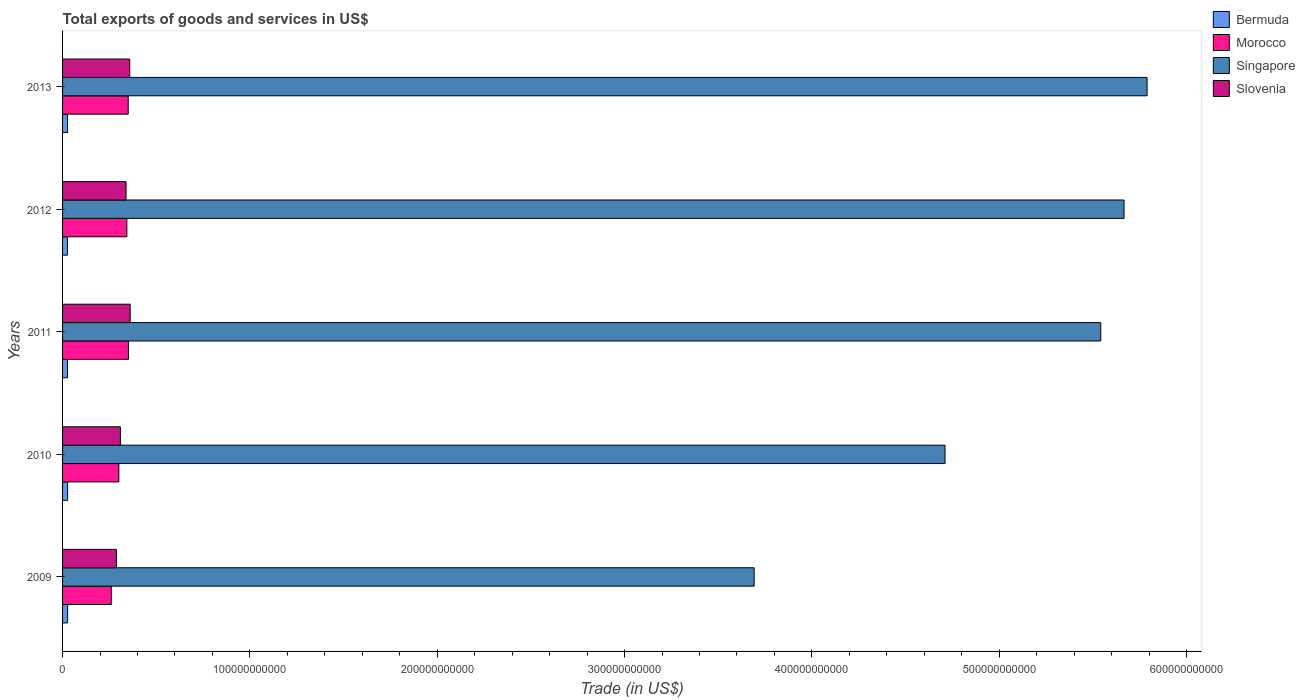How many different coloured bars are there?
Your response must be concise. 4. How many groups of bars are there?
Keep it short and to the point. 5. Are the number of bars per tick equal to the number of legend labels?
Your response must be concise. Yes. Are the number of bars on each tick of the Y-axis equal?
Ensure brevity in your answer.  Yes. In how many cases, is the number of bars for a given year not equal to the number of legend labels?
Your answer should be compact. 0. What is the total exports of goods and services in Bermuda in 2013?
Provide a succinct answer. 2.66e+09. Across all years, what is the maximum total exports of goods and services in Slovenia?
Your answer should be compact. 3.61e+1. Across all years, what is the minimum total exports of goods and services in Singapore?
Provide a short and direct response. 3.69e+11. In which year was the total exports of goods and services in Bermuda minimum?
Keep it short and to the point. 2012. What is the total total exports of goods and services in Bermuda in the graph?
Ensure brevity in your answer.  1.33e+1. What is the difference between the total exports of goods and services in Slovenia in 2009 and that in 2012?
Make the answer very short. -5.13e+09. What is the difference between the total exports of goods and services in Singapore in 2010 and the total exports of goods and services in Bermuda in 2011?
Provide a succinct answer. 4.68e+11. What is the average total exports of goods and services in Morocco per year?
Your answer should be very brief. 3.21e+1. In the year 2012, what is the difference between the total exports of goods and services in Bermuda and total exports of goods and services in Slovenia?
Keep it short and to the point. -3.13e+1. What is the ratio of the total exports of goods and services in Morocco in 2010 to that in 2012?
Give a very brief answer. 0.88. Is the total exports of goods and services in Morocco in 2011 less than that in 2012?
Provide a short and direct response. No. Is the difference between the total exports of goods and services in Bermuda in 2010 and 2011 greater than the difference between the total exports of goods and services in Slovenia in 2010 and 2011?
Provide a short and direct response. Yes. What is the difference between the highest and the second highest total exports of goods and services in Morocco?
Make the answer very short. 1.34e+08. What is the difference between the highest and the lowest total exports of goods and services in Morocco?
Your answer should be compact. 9.16e+09. Is it the case that in every year, the sum of the total exports of goods and services in Bermuda and total exports of goods and services in Singapore is greater than the sum of total exports of goods and services in Morocco and total exports of goods and services in Slovenia?
Give a very brief answer. Yes. What does the 1st bar from the top in 2013 represents?
Your answer should be very brief. Slovenia. What does the 3rd bar from the bottom in 2013 represents?
Your response must be concise. Singapore. How many bars are there?
Offer a terse response. 20. Are all the bars in the graph horizontal?
Your answer should be compact. Yes. What is the difference between two consecutive major ticks on the X-axis?
Your answer should be very brief. 1.00e+11. Does the graph contain any zero values?
Offer a very short reply. No. Does the graph contain grids?
Offer a very short reply. No. Where does the legend appear in the graph?
Ensure brevity in your answer.  Top right. What is the title of the graph?
Your response must be concise. Total exports of goods and services in US$. Does "Bhutan" appear as one of the legend labels in the graph?
Your answer should be very brief. No. What is the label or title of the X-axis?
Keep it short and to the point. Trade (in US$). What is the Trade (in US$) in Bermuda in 2009?
Make the answer very short. 2.70e+09. What is the Trade (in US$) in Morocco in 2009?
Offer a very short reply. 2.60e+1. What is the Trade (in US$) of Singapore in 2009?
Provide a succinct answer. 3.69e+11. What is the Trade (in US$) of Slovenia in 2009?
Keep it short and to the point. 2.88e+1. What is the Trade (in US$) in Bermuda in 2010?
Ensure brevity in your answer.  2.70e+09. What is the Trade (in US$) in Morocco in 2010?
Your response must be concise. 3.00e+1. What is the Trade (in US$) in Singapore in 2010?
Ensure brevity in your answer.  4.71e+11. What is the Trade (in US$) of Slovenia in 2010?
Offer a very short reply. 3.09e+1. What is the Trade (in US$) of Bermuda in 2011?
Make the answer very short. 2.64e+09. What is the Trade (in US$) in Morocco in 2011?
Keep it short and to the point. 3.52e+1. What is the Trade (in US$) in Singapore in 2011?
Give a very brief answer. 5.54e+11. What is the Trade (in US$) in Slovenia in 2011?
Make the answer very short. 3.61e+1. What is the Trade (in US$) in Bermuda in 2012?
Give a very brief answer. 2.59e+09. What is the Trade (in US$) in Morocco in 2012?
Offer a terse response. 3.43e+1. What is the Trade (in US$) of Singapore in 2012?
Offer a terse response. 5.67e+11. What is the Trade (in US$) in Slovenia in 2012?
Make the answer very short. 3.39e+1. What is the Trade (in US$) in Bermuda in 2013?
Provide a short and direct response. 2.66e+09. What is the Trade (in US$) in Morocco in 2013?
Make the answer very short. 3.50e+1. What is the Trade (in US$) in Singapore in 2013?
Make the answer very short. 5.79e+11. What is the Trade (in US$) of Slovenia in 2013?
Ensure brevity in your answer.  3.59e+1. Across all years, what is the maximum Trade (in US$) in Bermuda?
Your answer should be compact. 2.70e+09. Across all years, what is the maximum Trade (in US$) in Morocco?
Keep it short and to the point. 3.52e+1. Across all years, what is the maximum Trade (in US$) in Singapore?
Keep it short and to the point. 5.79e+11. Across all years, what is the maximum Trade (in US$) in Slovenia?
Offer a terse response. 3.61e+1. Across all years, what is the minimum Trade (in US$) in Bermuda?
Provide a short and direct response. 2.59e+09. Across all years, what is the minimum Trade (in US$) of Morocco?
Keep it short and to the point. 2.60e+1. Across all years, what is the minimum Trade (in US$) in Singapore?
Your response must be concise. 3.69e+11. Across all years, what is the minimum Trade (in US$) of Slovenia?
Your response must be concise. 2.88e+1. What is the total Trade (in US$) in Bermuda in the graph?
Provide a short and direct response. 1.33e+1. What is the total Trade (in US$) of Morocco in the graph?
Your answer should be very brief. 1.61e+11. What is the total Trade (in US$) in Singapore in the graph?
Ensure brevity in your answer.  2.54e+12. What is the total Trade (in US$) in Slovenia in the graph?
Keep it short and to the point. 1.65e+11. What is the difference between the Trade (in US$) in Bermuda in 2009 and that in 2010?
Make the answer very short. -5.34e+06. What is the difference between the Trade (in US$) in Morocco in 2009 and that in 2010?
Your answer should be compact. -4.03e+09. What is the difference between the Trade (in US$) of Singapore in 2009 and that in 2010?
Ensure brevity in your answer.  -1.02e+11. What is the difference between the Trade (in US$) of Slovenia in 2009 and that in 2010?
Provide a succinct answer. -2.11e+09. What is the difference between the Trade (in US$) of Bermuda in 2009 and that in 2011?
Your response must be concise. 5.51e+07. What is the difference between the Trade (in US$) of Morocco in 2009 and that in 2011?
Offer a terse response. -9.16e+09. What is the difference between the Trade (in US$) in Singapore in 2009 and that in 2011?
Offer a very short reply. -1.85e+11. What is the difference between the Trade (in US$) of Slovenia in 2009 and that in 2011?
Offer a terse response. -7.33e+09. What is the difference between the Trade (in US$) of Bermuda in 2009 and that in 2012?
Offer a very short reply. 1.10e+08. What is the difference between the Trade (in US$) in Morocco in 2009 and that in 2012?
Provide a short and direct response. -8.31e+09. What is the difference between the Trade (in US$) in Singapore in 2009 and that in 2012?
Make the answer very short. -1.97e+11. What is the difference between the Trade (in US$) of Slovenia in 2009 and that in 2012?
Make the answer very short. -5.13e+09. What is the difference between the Trade (in US$) of Bermuda in 2009 and that in 2013?
Provide a succinct answer. 4.24e+07. What is the difference between the Trade (in US$) in Morocco in 2009 and that in 2013?
Offer a terse response. -9.03e+09. What is the difference between the Trade (in US$) of Singapore in 2009 and that in 2013?
Ensure brevity in your answer.  -2.10e+11. What is the difference between the Trade (in US$) of Slovenia in 2009 and that in 2013?
Keep it short and to the point. -7.09e+09. What is the difference between the Trade (in US$) of Bermuda in 2010 and that in 2011?
Your answer should be very brief. 6.04e+07. What is the difference between the Trade (in US$) of Morocco in 2010 and that in 2011?
Make the answer very short. -5.13e+09. What is the difference between the Trade (in US$) in Singapore in 2010 and that in 2011?
Offer a very short reply. -8.31e+1. What is the difference between the Trade (in US$) of Slovenia in 2010 and that in 2011?
Offer a very short reply. -5.22e+09. What is the difference between the Trade (in US$) of Bermuda in 2010 and that in 2012?
Give a very brief answer. 1.15e+08. What is the difference between the Trade (in US$) of Morocco in 2010 and that in 2012?
Give a very brief answer. -4.28e+09. What is the difference between the Trade (in US$) of Singapore in 2010 and that in 2012?
Offer a terse response. -9.56e+1. What is the difference between the Trade (in US$) in Slovenia in 2010 and that in 2012?
Provide a succinct answer. -3.03e+09. What is the difference between the Trade (in US$) of Bermuda in 2010 and that in 2013?
Provide a short and direct response. 4.78e+07. What is the difference between the Trade (in US$) in Morocco in 2010 and that in 2013?
Provide a short and direct response. -5.00e+09. What is the difference between the Trade (in US$) of Singapore in 2010 and that in 2013?
Offer a very short reply. -1.08e+11. What is the difference between the Trade (in US$) in Slovenia in 2010 and that in 2013?
Your response must be concise. -4.99e+09. What is the difference between the Trade (in US$) in Bermuda in 2011 and that in 2012?
Keep it short and to the point. 5.48e+07. What is the difference between the Trade (in US$) in Morocco in 2011 and that in 2012?
Offer a terse response. 8.52e+08. What is the difference between the Trade (in US$) in Singapore in 2011 and that in 2012?
Make the answer very short. -1.24e+1. What is the difference between the Trade (in US$) in Slovenia in 2011 and that in 2012?
Give a very brief answer. 2.20e+09. What is the difference between the Trade (in US$) of Bermuda in 2011 and that in 2013?
Your answer should be very brief. -1.27e+07. What is the difference between the Trade (in US$) in Morocco in 2011 and that in 2013?
Provide a short and direct response. 1.34e+08. What is the difference between the Trade (in US$) in Singapore in 2011 and that in 2013?
Ensure brevity in your answer.  -2.47e+1. What is the difference between the Trade (in US$) of Slovenia in 2011 and that in 2013?
Your answer should be compact. 2.38e+08. What is the difference between the Trade (in US$) of Bermuda in 2012 and that in 2013?
Provide a short and direct response. -6.75e+07. What is the difference between the Trade (in US$) in Morocco in 2012 and that in 2013?
Give a very brief answer. -7.18e+08. What is the difference between the Trade (in US$) in Singapore in 2012 and that in 2013?
Offer a terse response. -1.23e+1. What is the difference between the Trade (in US$) in Slovenia in 2012 and that in 2013?
Offer a terse response. -1.96e+09. What is the difference between the Trade (in US$) of Bermuda in 2009 and the Trade (in US$) of Morocco in 2010?
Keep it short and to the point. -2.73e+1. What is the difference between the Trade (in US$) of Bermuda in 2009 and the Trade (in US$) of Singapore in 2010?
Offer a very short reply. -4.68e+11. What is the difference between the Trade (in US$) of Bermuda in 2009 and the Trade (in US$) of Slovenia in 2010?
Provide a short and direct response. -2.82e+1. What is the difference between the Trade (in US$) in Morocco in 2009 and the Trade (in US$) in Singapore in 2010?
Provide a succinct answer. -4.45e+11. What is the difference between the Trade (in US$) of Morocco in 2009 and the Trade (in US$) of Slovenia in 2010?
Your response must be concise. -4.85e+09. What is the difference between the Trade (in US$) in Singapore in 2009 and the Trade (in US$) in Slovenia in 2010?
Give a very brief answer. 3.38e+11. What is the difference between the Trade (in US$) of Bermuda in 2009 and the Trade (in US$) of Morocco in 2011?
Give a very brief answer. -3.25e+1. What is the difference between the Trade (in US$) in Bermuda in 2009 and the Trade (in US$) in Singapore in 2011?
Provide a succinct answer. -5.52e+11. What is the difference between the Trade (in US$) in Bermuda in 2009 and the Trade (in US$) in Slovenia in 2011?
Ensure brevity in your answer.  -3.34e+1. What is the difference between the Trade (in US$) in Morocco in 2009 and the Trade (in US$) in Singapore in 2011?
Your answer should be very brief. -5.28e+11. What is the difference between the Trade (in US$) in Morocco in 2009 and the Trade (in US$) in Slovenia in 2011?
Keep it short and to the point. -1.01e+1. What is the difference between the Trade (in US$) in Singapore in 2009 and the Trade (in US$) in Slovenia in 2011?
Give a very brief answer. 3.33e+11. What is the difference between the Trade (in US$) of Bermuda in 2009 and the Trade (in US$) of Morocco in 2012?
Ensure brevity in your answer.  -3.16e+1. What is the difference between the Trade (in US$) in Bermuda in 2009 and the Trade (in US$) in Singapore in 2012?
Offer a very short reply. -5.64e+11. What is the difference between the Trade (in US$) of Bermuda in 2009 and the Trade (in US$) of Slovenia in 2012?
Make the answer very short. -3.12e+1. What is the difference between the Trade (in US$) in Morocco in 2009 and the Trade (in US$) in Singapore in 2012?
Make the answer very short. -5.41e+11. What is the difference between the Trade (in US$) in Morocco in 2009 and the Trade (in US$) in Slovenia in 2012?
Keep it short and to the point. -7.88e+09. What is the difference between the Trade (in US$) in Singapore in 2009 and the Trade (in US$) in Slovenia in 2012?
Provide a short and direct response. 3.35e+11. What is the difference between the Trade (in US$) of Bermuda in 2009 and the Trade (in US$) of Morocco in 2013?
Provide a succinct answer. -3.23e+1. What is the difference between the Trade (in US$) in Bermuda in 2009 and the Trade (in US$) in Singapore in 2013?
Provide a succinct answer. -5.76e+11. What is the difference between the Trade (in US$) of Bermuda in 2009 and the Trade (in US$) of Slovenia in 2013?
Your response must be concise. -3.32e+1. What is the difference between the Trade (in US$) in Morocco in 2009 and the Trade (in US$) in Singapore in 2013?
Give a very brief answer. -5.53e+11. What is the difference between the Trade (in US$) in Morocco in 2009 and the Trade (in US$) in Slovenia in 2013?
Your answer should be very brief. -9.84e+09. What is the difference between the Trade (in US$) of Singapore in 2009 and the Trade (in US$) of Slovenia in 2013?
Make the answer very short. 3.33e+11. What is the difference between the Trade (in US$) of Bermuda in 2010 and the Trade (in US$) of Morocco in 2011?
Offer a very short reply. -3.25e+1. What is the difference between the Trade (in US$) in Bermuda in 2010 and the Trade (in US$) in Singapore in 2011?
Provide a short and direct response. -5.52e+11. What is the difference between the Trade (in US$) in Bermuda in 2010 and the Trade (in US$) in Slovenia in 2011?
Provide a short and direct response. -3.34e+1. What is the difference between the Trade (in US$) of Morocco in 2010 and the Trade (in US$) of Singapore in 2011?
Your response must be concise. -5.24e+11. What is the difference between the Trade (in US$) in Morocco in 2010 and the Trade (in US$) in Slovenia in 2011?
Offer a very short reply. -6.05e+09. What is the difference between the Trade (in US$) in Singapore in 2010 and the Trade (in US$) in Slovenia in 2011?
Provide a short and direct response. 4.35e+11. What is the difference between the Trade (in US$) in Bermuda in 2010 and the Trade (in US$) in Morocco in 2012?
Give a very brief answer. -3.16e+1. What is the difference between the Trade (in US$) of Bermuda in 2010 and the Trade (in US$) of Singapore in 2012?
Make the answer very short. -5.64e+11. What is the difference between the Trade (in US$) of Bermuda in 2010 and the Trade (in US$) of Slovenia in 2012?
Your answer should be very brief. -3.12e+1. What is the difference between the Trade (in US$) of Morocco in 2010 and the Trade (in US$) of Singapore in 2012?
Your answer should be very brief. -5.37e+11. What is the difference between the Trade (in US$) in Morocco in 2010 and the Trade (in US$) in Slovenia in 2012?
Keep it short and to the point. -3.85e+09. What is the difference between the Trade (in US$) in Singapore in 2010 and the Trade (in US$) in Slovenia in 2012?
Your answer should be compact. 4.37e+11. What is the difference between the Trade (in US$) of Bermuda in 2010 and the Trade (in US$) of Morocco in 2013?
Give a very brief answer. -3.23e+1. What is the difference between the Trade (in US$) of Bermuda in 2010 and the Trade (in US$) of Singapore in 2013?
Give a very brief answer. -5.76e+11. What is the difference between the Trade (in US$) in Bermuda in 2010 and the Trade (in US$) in Slovenia in 2013?
Make the answer very short. -3.32e+1. What is the difference between the Trade (in US$) in Morocco in 2010 and the Trade (in US$) in Singapore in 2013?
Your answer should be very brief. -5.49e+11. What is the difference between the Trade (in US$) in Morocco in 2010 and the Trade (in US$) in Slovenia in 2013?
Give a very brief answer. -5.81e+09. What is the difference between the Trade (in US$) of Singapore in 2010 and the Trade (in US$) of Slovenia in 2013?
Keep it short and to the point. 4.35e+11. What is the difference between the Trade (in US$) in Bermuda in 2011 and the Trade (in US$) in Morocco in 2012?
Keep it short and to the point. -3.17e+1. What is the difference between the Trade (in US$) in Bermuda in 2011 and the Trade (in US$) in Singapore in 2012?
Keep it short and to the point. -5.64e+11. What is the difference between the Trade (in US$) in Bermuda in 2011 and the Trade (in US$) in Slovenia in 2012?
Your answer should be compact. -3.13e+1. What is the difference between the Trade (in US$) of Morocco in 2011 and the Trade (in US$) of Singapore in 2012?
Offer a terse response. -5.31e+11. What is the difference between the Trade (in US$) of Morocco in 2011 and the Trade (in US$) of Slovenia in 2012?
Provide a short and direct response. 1.28e+09. What is the difference between the Trade (in US$) in Singapore in 2011 and the Trade (in US$) in Slovenia in 2012?
Provide a short and direct response. 5.20e+11. What is the difference between the Trade (in US$) of Bermuda in 2011 and the Trade (in US$) of Morocco in 2013?
Offer a very short reply. -3.24e+1. What is the difference between the Trade (in US$) of Bermuda in 2011 and the Trade (in US$) of Singapore in 2013?
Your response must be concise. -5.76e+11. What is the difference between the Trade (in US$) in Bermuda in 2011 and the Trade (in US$) in Slovenia in 2013?
Your response must be concise. -3.32e+1. What is the difference between the Trade (in US$) of Morocco in 2011 and the Trade (in US$) of Singapore in 2013?
Your answer should be compact. -5.44e+11. What is the difference between the Trade (in US$) of Morocco in 2011 and the Trade (in US$) of Slovenia in 2013?
Your answer should be compact. -6.80e+08. What is the difference between the Trade (in US$) of Singapore in 2011 and the Trade (in US$) of Slovenia in 2013?
Provide a short and direct response. 5.18e+11. What is the difference between the Trade (in US$) in Bermuda in 2012 and the Trade (in US$) in Morocco in 2013?
Your answer should be very brief. -3.25e+1. What is the difference between the Trade (in US$) of Bermuda in 2012 and the Trade (in US$) of Singapore in 2013?
Give a very brief answer. -5.76e+11. What is the difference between the Trade (in US$) in Bermuda in 2012 and the Trade (in US$) in Slovenia in 2013?
Offer a terse response. -3.33e+1. What is the difference between the Trade (in US$) of Morocco in 2012 and the Trade (in US$) of Singapore in 2013?
Keep it short and to the point. -5.45e+11. What is the difference between the Trade (in US$) of Morocco in 2012 and the Trade (in US$) of Slovenia in 2013?
Ensure brevity in your answer.  -1.53e+09. What is the difference between the Trade (in US$) in Singapore in 2012 and the Trade (in US$) in Slovenia in 2013?
Your answer should be very brief. 5.31e+11. What is the average Trade (in US$) of Bermuda per year?
Your answer should be compact. 2.66e+09. What is the average Trade (in US$) in Morocco per year?
Make the answer very short. 3.21e+1. What is the average Trade (in US$) in Singapore per year?
Provide a succinct answer. 5.08e+11. What is the average Trade (in US$) in Slovenia per year?
Provide a short and direct response. 3.31e+1. In the year 2009, what is the difference between the Trade (in US$) in Bermuda and Trade (in US$) in Morocco?
Your answer should be compact. -2.33e+1. In the year 2009, what is the difference between the Trade (in US$) in Bermuda and Trade (in US$) in Singapore?
Ensure brevity in your answer.  -3.66e+11. In the year 2009, what is the difference between the Trade (in US$) of Bermuda and Trade (in US$) of Slovenia?
Keep it short and to the point. -2.61e+1. In the year 2009, what is the difference between the Trade (in US$) of Morocco and Trade (in US$) of Singapore?
Keep it short and to the point. -3.43e+11. In the year 2009, what is the difference between the Trade (in US$) of Morocco and Trade (in US$) of Slovenia?
Ensure brevity in your answer.  -2.75e+09. In the year 2009, what is the difference between the Trade (in US$) of Singapore and Trade (in US$) of Slovenia?
Provide a short and direct response. 3.40e+11. In the year 2010, what is the difference between the Trade (in US$) in Bermuda and Trade (in US$) in Morocco?
Your response must be concise. -2.73e+1. In the year 2010, what is the difference between the Trade (in US$) in Bermuda and Trade (in US$) in Singapore?
Your answer should be very brief. -4.68e+11. In the year 2010, what is the difference between the Trade (in US$) in Bermuda and Trade (in US$) in Slovenia?
Offer a very short reply. -2.82e+1. In the year 2010, what is the difference between the Trade (in US$) of Morocco and Trade (in US$) of Singapore?
Your answer should be compact. -4.41e+11. In the year 2010, what is the difference between the Trade (in US$) of Morocco and Trade (in US$) of Slovenia?
Offer a terse response. -8.22e+08. In the year 2010, what is the difference between the Trade (in US$) in Singapore and Trade (in US$) in Slovenia?
Provide a succinct answer. 4.40e+11. In the year 2011, what is the difference between the Trade (in US$) in Bermuda and Trade (in US$) in Morocco?
Give a very brief answer. -3.25e+1. In the year 2011, what is the difference between the Trade (in US$) of Bermuda and Trade (in US$) of Singapore?
Make the answer very short. -5.52e+11. In the year 2011, what is the difference between the Trade (in US$) in Bermuda and Trade (in US$) in Slovenia?
Offer a very short reply. -3.34e+1. In the year 2011, what is the difference between the Trade (in US$) in Morocco and Trade (in US$) in Singapore?
Make the answer very short. -5.19e+11. In the year 2011, what is the difference between the Trade (in US$) of Morocco and Trade (in US$) of Slovenia?
Keep it short and to the point. -9.18e+08. In the year 2011, what is the difference between the Trade (in US$) in Singapore and Trade (in US$) in Slovenia?
Make the answer very short. 5.18e+11. In the year 2012, what is the difference between the Trade (in US$) of Bermuda and Trade (in US$) of Morocco?
Keep it short and to the point. -3.17e+1. In the year 2012, what is the difference between the Trade (in US$) of Bermuda and Trade (in US$) of Singapore?
Offer a very short reply. -5.64e+11. In the year 2012, what is the difference between the Trade (in US$) in Bermuda and Trade (in US$) in Slovenia?
Your answer should be compact. -3.13e+1. In the year 2012, what is the difference between the Trade (in US$) in Morocco and Trade (in US$) in Singapore?
Make the answer very short. -5.32e+11. In the year 2012, what is the difference between the Trade (in US$) in Morocco and Trade (in US$) in Slovenia?
Your answer should be very brief. 4.29e+08. In the year 2012, what is the difference between the Trade (in US$) in Singapore and Trade (in US$) in Slovenia?
Offer a terse response. 5.33e+11. In the year 2013, what is the difference between the Trade (in US$) in Bermuda and Trade (in US$) in Morocco?
Offer a very short reply. -3.24e+1. In the year 2013, what is the difference between the Trade (in US$) of Bermuda and Trade (in US$) of Singapore?
Offer a terse response. -5.76e+11. In the year 2013, what is the difference between the Trade (in US$) in Bermuda and Trade (in US$) in Slovenia?
Your answer should be very brief. -3.32e+1. In the year 2013, what is the difference between the Trade (in US$) of Morocco and Trade (in US$) of Singapore?
Your answer should be compact. -5.44e+11. In the year 2013, what is the difference between the Trade (in US$) of Morocco and Trade (in US$) of Slovenia?
Make the answer very short. -8.14e+08. In the year 2013, what is the difference between the Trade (in US$) in Singapore and Trade (in US$) in Slovenia?
Provide a succinct answer. 5.43e+11. What is the ratio of the Trade (in US$) of Bermuda in 2009 to that in 2010?
Provide a succinct answer. 1. What is the ratio of the Trade (in US$) in Morocco in 2009 to that in 2010?
Your response must be concise. 0.87. What is the ratio of the Trade (in US$) of Singapore in 2009 to that in 2010?
Provide a succinct answer. 0.78. What is the ratio of the Trade (in US$) in Slovenia in 2009 to that in 2010?
Ensure brevity in your answer.  0.93. What is the ratio of the Trade (in US$) in Bermuda in 2009 to that in 2011?
Give a very brief answer. 1.02. What is the ratio of the Trade (in US$) in Morocco in 2009 to that in 2011?
Your answer should be compact. 0.74. What is the ratio of the Trade (in US$) of Singapore in 2009 to that in 2011?
Provide a succinct answer. 0.67. What is the ratio of the Trade (in US$) in Slovenia in 2009 to that in 2011?
Keep it short and to the point. 0.8. What is the ratio of the Trade (in US$) of Bermuda in 2009 to that in 2012?
Your answer should be compact. 1.04. What is the ratio of the Trade (in US$) of Morocco in 2009 to that in 2012?
Your answer should be very brief. 0.76. What is the ratio of the Trade (in US$) of Singapore in 2009 to that in 2012?
Your answer should be very brief. 0.65. What is the ratio of the Trade (in US$) of Slovenia in 2009 to that in 2012?
Your answer should be very brief. 0.85. What is the ratio of the Trade (in US$) in Morocco in 2009 to that in 2013?
Provide a short and direct response. 0.74. What is the ratio of the Trade (in US$) of Singapore in 2009 to that in 2013?
Your answer should be very brief. 0.64. What is the ratio of the Trade (in US$) in Slovenia in 2009 to that in 2013?
Keep it short and to the point. 0.8. What is the ratio of the Trade (in US$) of Bermuda in 2010 to that in 2011?
Your response must be concise. 1.02. What is the ratio of the Trade (in US$) of Morocco in 2010 to that in 2011?
Your answer should be very brief. 0.85. What is the ratio of the Trade (in US$) in Singapore in 2010 to that in 2011?
Offer a very short reply. 0.85. What is the ratio of the Trade (in US$) of Slovenia in 2010 to that in 2011?
Your response must be concise. 0.86. What is the ratio of the Trade (in US$) of Bermuda in 2010 to that in 2012?
Your answer should be very brief. 1.04. What is the ratio of the Trade (in US$) in Morocco in 2010 to that in 2012?
Offer a terse response. 0.88. What is the ratio of the Trade (in US$) of Singapore in 2010 to that in 2012?
Your response must be concise. 0.83. What is the ratio of the Trade (in US$) in Slovenia in 2010 to that in 2012?
Ensure brevity in your answer.  0.91. What is the ratio of the Trade (in US$) in Bermuda in 2010 to that in 2013?
Provide a short and direct response. 1.02. What is the ratio of the Trade (in US$) in Morocco in 2010 to that in 2013?
Your response must be concise. 0.86. What is the ratio of the Trade (in US$) of Singapore in 2010 to that in 2013?
Provide a succinct answer. 0.81. What is the ratio of the Trade (in US$) of Slovenia in 2010 to that in 2013?
Make the answer very short. 0.86. What is the ratio of the Trade (in US$) in Bermuda in 2011 to that in 2012?
Keep it short and to the point. 1.02. What is the ratio of the Trade (in US$) of Morocco in 2011 to that in 2012?
Ensure brevity in your answer.  1.02. What is the ratio of the Trade (in US$) in Singapore in 2011 to that in 2012?
Offer a terse response. 0.98. What is the ratio of the Trade (in US$) of Slovenia in 2011 to that in 2012?
Provide a short and direct response. 1.06. What is the ratio of the Trade (in US$) of Morocco in 2011 to that in 2013?
Offer a terse response. 1. What is the ratio of the Trade (in US$) in Singapore in 2011 to that in 2013?
Keep it short and to the point. 0.96. What is the ratio of the Trade (in US$) of Slovenia in 2011 to that in 2013?
Give a very brief answer. 1.01. What is the ratio of the Trade (in US$) of Bermuda in 2012 to that in 2013?
Give a very brief answer. 0.97. What is the ratio of the Trade (in US$) in Morocco in 2012 to that in 2013?
Offer a terse response. 0.98. What is the ratio of the Trade (in US$) in Singapore in 2012 to that in 2013?
Provide a succinct answer. 0.98. What is the ratio of the Trade (in US$) in Slovenia in 2012 to that in 2013?
Your response must be concise. 0.95. What is the difference between the highest and the second highest Trade (in US$) in Bermuda?
Offer a very short reply. 5.34e+06. What is the difference between the highest and the second highest Trade (in US$) in Morocco?
Give a very brief answer. 1.34e+08. What is the difference between the highest and the second highest Trade (in US$) in Singapore?
Your answer should be very brief. 1.23e+1. What is the difference between the highest and the second highest Trade (in US$) of Slovenia?
Offer a very short reply. 2.38e+08. What is the difference between the highest and the lowest Trade (in US$) in Bermuda?
Keep it short and to the point. 1.15e+08. What is the difference between the highest and the lowest Trade (in US$) in Morocco?
Keep it short and to the point. 9.16e+09. What is the difference between the highest and the lowest Trade (in US$) in Singapore?
Keep it short and to the point. 2.10e+11. What is the difference between the highest and the lowest Trade (in US$) of Slovenia?
Ensure brevity in your answer.  7.33e+09. 